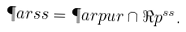<formula> <loc_0><loc_0><loc_500><loc_500>\P a r s s = \P a r p u r \cap \Re p ^ { s s } .</formula> 